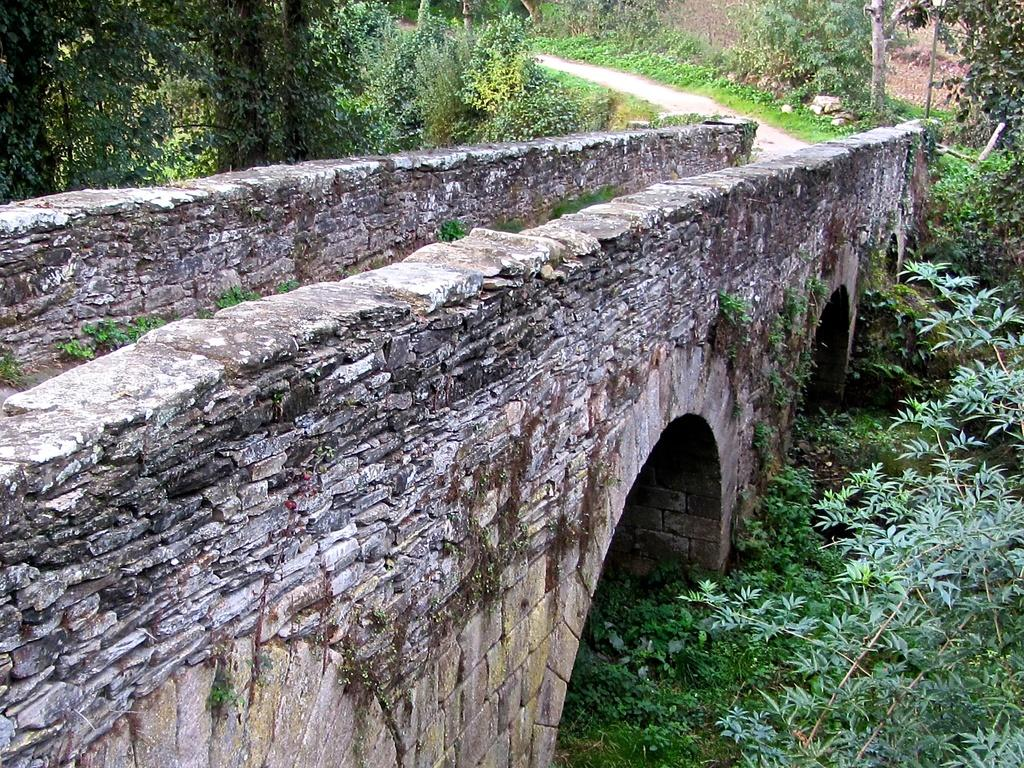What type of structure can be seen in the image? There is a bridge in the image. What else is present in the image besides the bridge? There is a road in the image. What can be seen on both sides of the road? There are trees and plants on both sides of the road. What type of skin condition can be seen on the bridge in the image? There is no skin condition present in the image, as the bridge is a structure and not a living organism. 